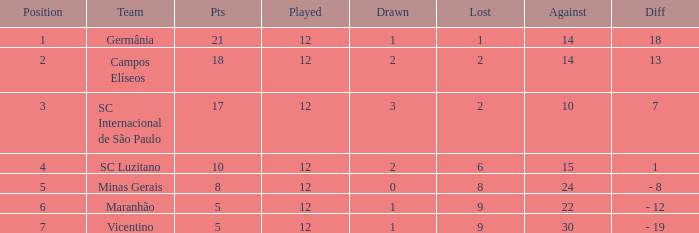What is the sum of drawn that has a played more than 12? 0.0. 